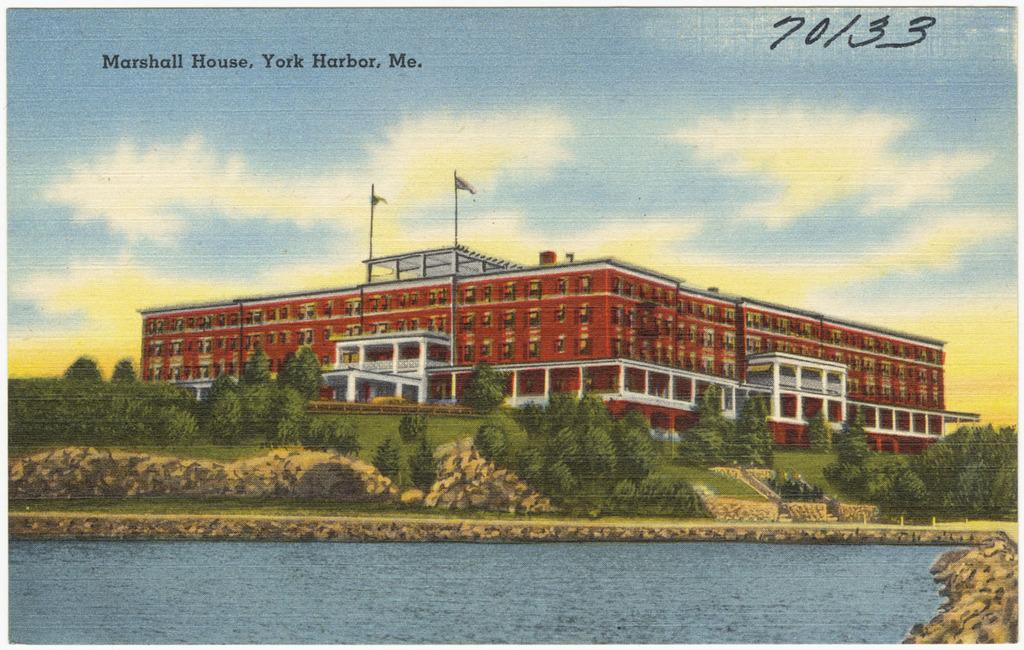<image>
Offer a succinct explanation of the picture presented. A picture of a large red building with water in front called  the Marshall House in York Harbor, Maine.of 